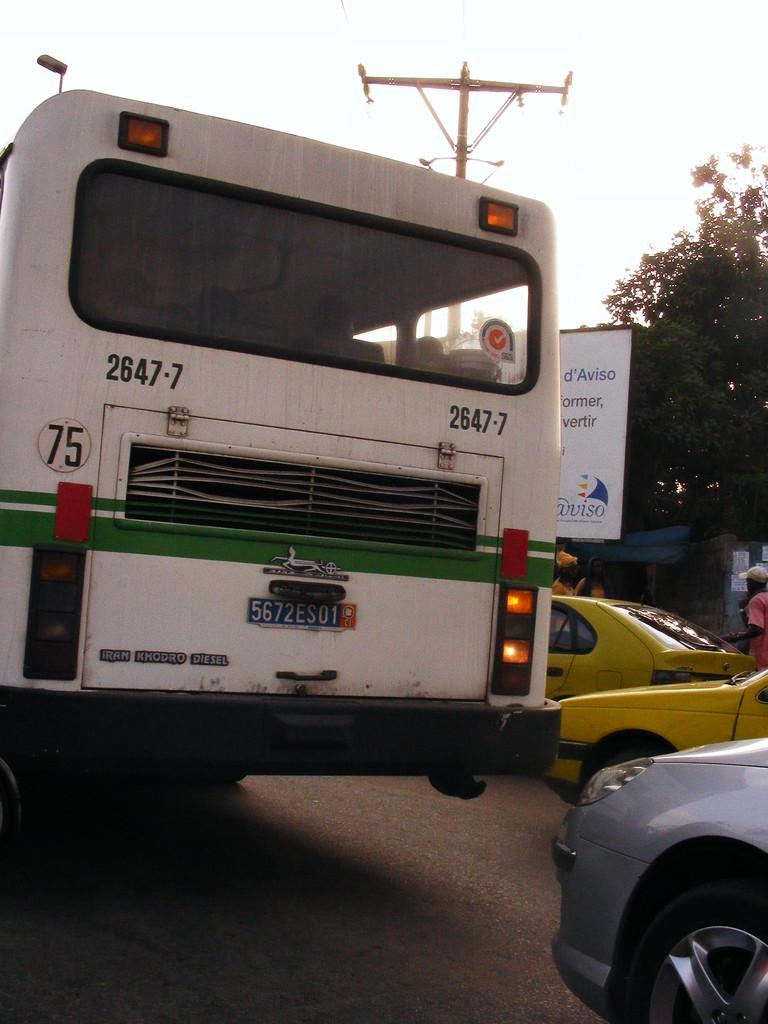What types of vehicles can be seen on the road in the image? There are cars and buses on the road in the image. What structure is visible in the image? There is a tower visible in the image. What object can be seen in the image that might display information or advertisements? There is a board in the image. What type of vegetation is present in the image? There are trees in the image. What is visible at the top of the image? The sky is visible at the top of the image. How many bulbs are hanging from the trees in the image? There are no bulbs hanging from the trees in the image; only trees are present. What type of pets can be seen playing with the cars in the image? There are no pets visible in the image; only cars, buses, a tower, a board, trees, and the sky are present. 